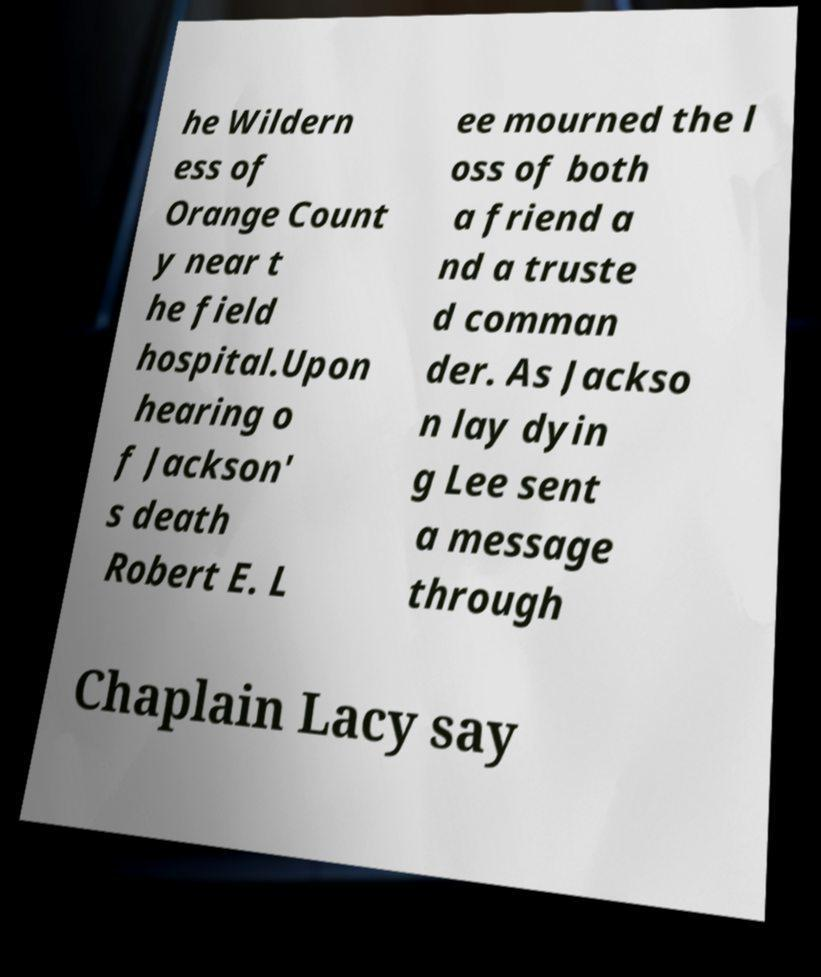Can you read and provide the text displayed in the image?This photo seems to have some interesting text. Can you extract and type it out for me? he Wildern ess of Orange Count y near t he field hospital.Upon hearing o f Jackson' s death Robert E. L ee mourned the l oss of both a friend a nd a truste d comman der. As Jackso n lay dyin g Lee sent a message through Chaplain Lacy say 